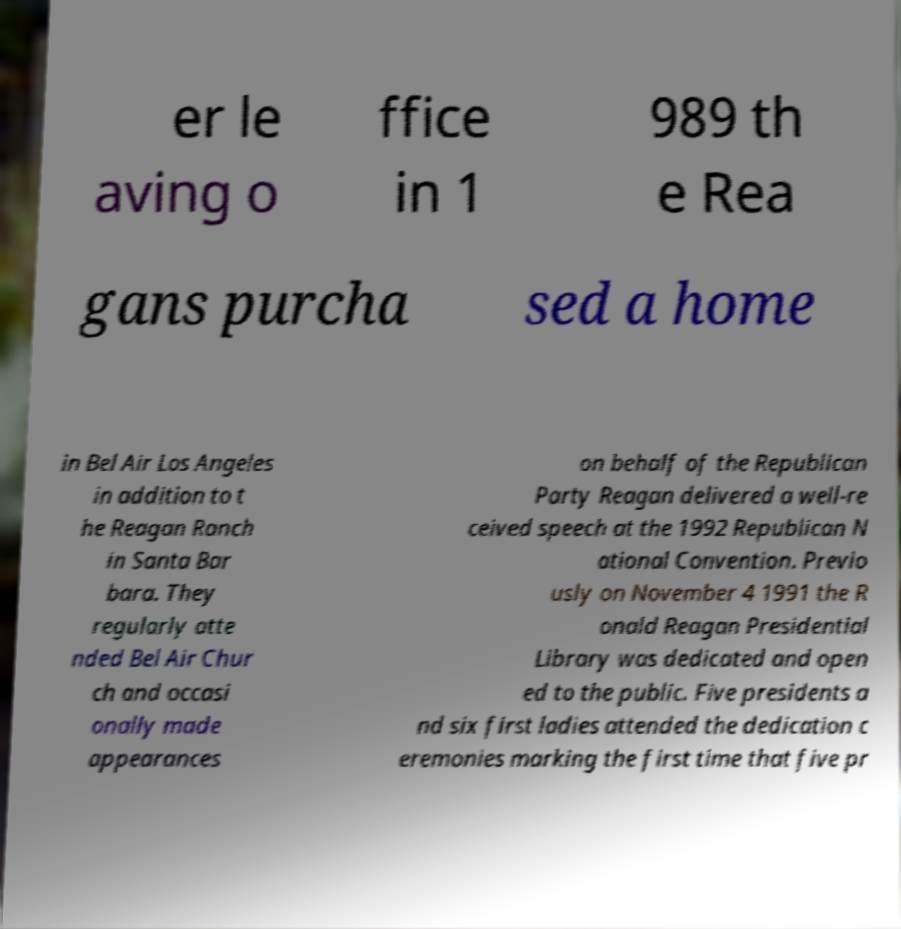Could you assist in decoding the text presented in this image and type it out clearly? er le aving o ffice in 1 989 th e Rea gans purcha sed a home in Bel Air Los Angeles in addition to t he Reagan Ranch in Santa Bar bara. They regularly atte nded Bel Air Chur ch and occasi onally made appearances on behalf of the Republican Party Reagan delivered a well-re ceived speech at the 1992 Republican N ational Convention. Previo usly on November 4 1991 the R onald Reagan Presidential Library was dedicated and open ed to the public. Five presidents a nd six first ladies attended the dedication c eremonies marking the first time that five pr 